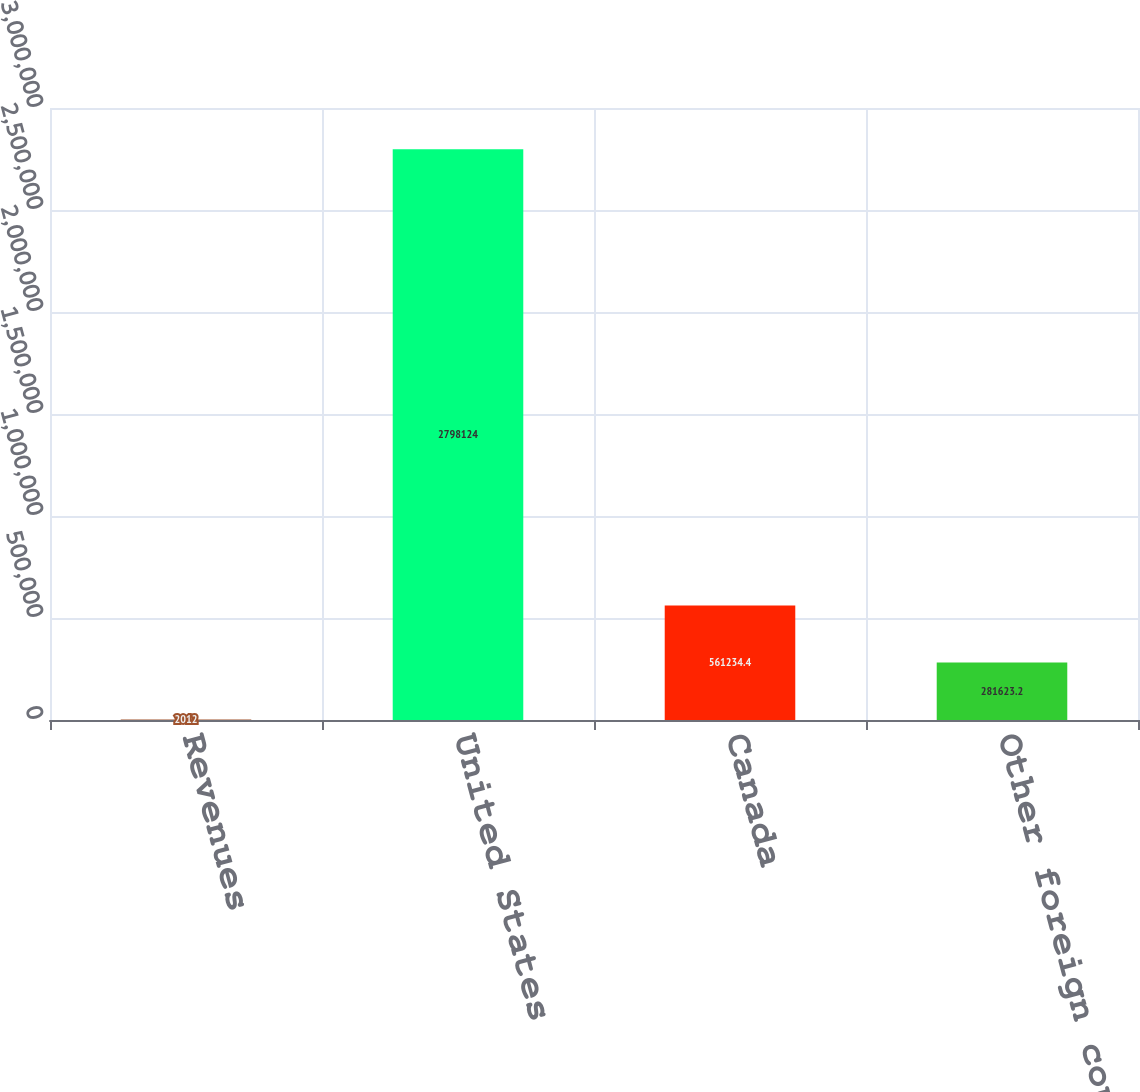Convert chart to OTSL. <chart><loc_0><loc_0><loc_500><loc_500><bar_chart><fcel>Revenues<fcel>United States<fcel>Canada<fcel>Other foreign countries<nl><fcel>2012<fcel>2.79812e+06<fcel>561234<fcel>281623<nl></chart> 